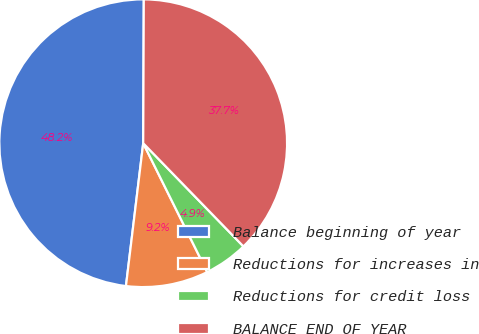<chart> <loc_0><loc_0><loc_500><loc_500><pie_chart><fcel>Balance beginning of year<fcel>Reductions for increases in<fcel>Reductions for credit loss<fcel>BALANCE END OF YEAR<nl><fcel>48.15%<fcel>9.25%<fcel>4.93%<fcel>37.67%<nl></chart> 